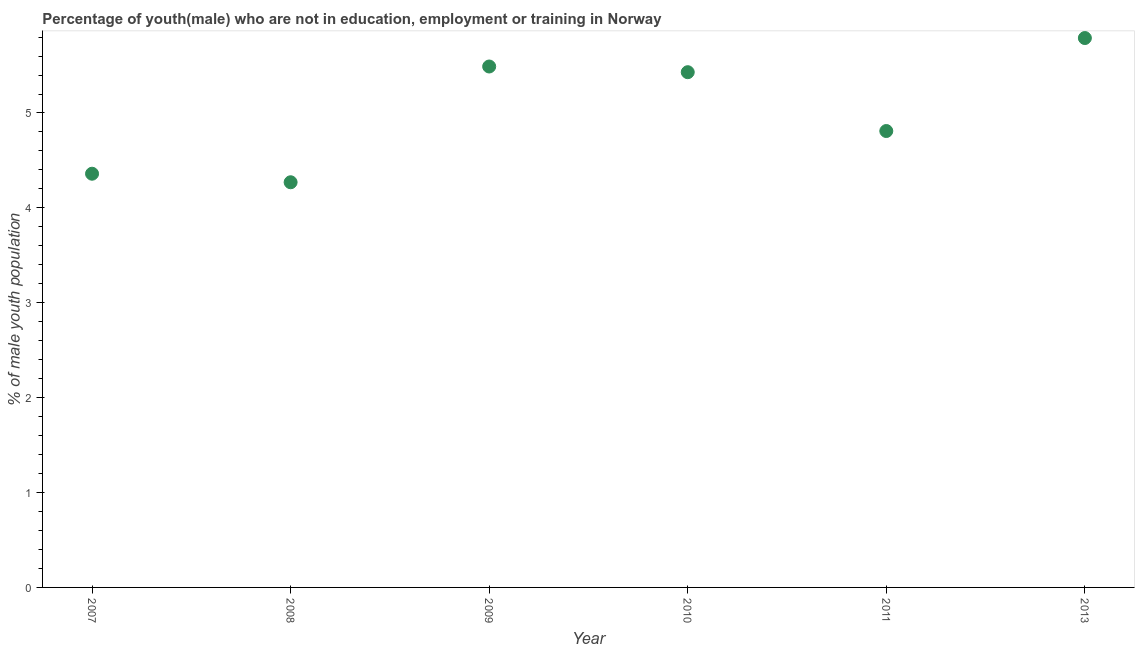What is the unemployed male youth population in 2013?
Your response must be concise. 5.79. Across all years, what is the maximum unemployed male youth population?
Your answer should be very brief. 5.79. Across all years, what is the minimum unemployed male youth population?
Your answer should be compact. 4.27. In which year was the unemployed male youth population maximum?
Offer a very short reply. 2013. What is the sum of the unemployed male youth population?
Offer a terse response. 30.15. What is the difference between the unemployed male youth population in 2008 and 2011?
Your answer should be very brief. -0.54. What is the average unemployed male youth population per year?
Make the answer very short. 5.02. What is the median unemployed male youth population?
Provide a short and direct response. 5.12. In how many years, is the unemployed male youth population greater than 0.8 %?
Provide a succinct answer. 6. What is the ratio of the unemployed male youth population in 2008 to that in 2009?
Provide a short and direct response. 0.78. Is the unemployed male youth population in 2011 less than that in 2013?
Your response must be concise. Yes. Is the difference between the unemployed male youth population in 2008 and 2013 greater than the difference between any two years?
Offer a very short reply. Yes. What is the difference between the highest and the second highest unemployed male youth population?
Make the answer very short. 0.3. What is the difference between the highest and the lowest unemployed male youth population?
Provide a short and direct response. 1.52. Does the unemployed male youth population monotonically increase over the years?
Provide a succinct answer. No. How many dotlines are there?
Offer a terse response. 1. What is the difference between two consecutive major ticks on the Y-axis?
Your answer should be compact. 1. Are the values on the major ticks of Y-axis written in scientific E-notation?
Your answer should be compact. No. What is the title of the graph?
Offer a very short reply. Percentage of youth(male) who are not in education, employment or training in Norway. What is the label or title of the X-axis?
Your response must be concise. Year. What is the label or title of the Y-axis?
Provide a succinct answer. % of male youth population. What is the % of male youth population in 2007?
Provide a short and direct response. 4.36. What is the % of male youth population in 2008?
Provide a short and direct response. 4.27. What is the % of male youth population in 2009?
Give a very brief answer. 5.49. What is the % of male youth population in 2010?
Provide a succinct answer. 5.43. What is the % of male youth population in 2011?
Give a very brief answer. 4.81. What is the % of male youth population in 2013?
Give a very brief answer. 5.79. What is the difference between the % of male youth population in 2007 and 2008?
Give a very brief answer. 0.09. What is the difference between the % of male youth population in 2007 and 2009?
Keep it short and to the point. -1.13. What is the difference between the % of male youth population in 2007 and 2010?
Offer a very short reply. -1.07. What is the difference between the % of male youth population in 2007 and 2011?
Your answer should be compact. -0.45. What is the difference between the % of male youth population in 2007 and 2013?
Make the answer very short. -1.43. What is the difference between the % of male youth population in 2008 and 2009?
Keep it short and to the point. -1.22. What is the difference between the % of male youth population in 2008 and 2010?
Your response must be concise. -1.16. What is the difference between the % of male youth population in 2008 and 2011?
Your answer should be compact. -0.54. What is the difference between the % of male youth population in 2008 and 2013?
Make the answer very short. -1.52. What is the difference between the % of male youth population in 2009 and 2010?
Make the answer very short. 0.06. What is the difference between the % of male youth population in 2009 and 2011?
Offer a terse response. 0.68. What is the difference between the % of male youth population in 2010 and 2011?
Your answer should be very brief. 0.62. What is the difference between the % of male youth population in 2010 and 2013?
Ensure brevity in your answer.  -0.36. What is the difference between the % of male youth population in 2011 and 2013?
Offer a very short reply. -0.98. What is the ratio of the % of male youth population in 2007 to that in 2009?
Give a very brief answer. 0.79. What is the ratio of the % of male youth population in 2007 to that in 2010?
Your answer should be very brief. 0.8. What is the ratio of the % of male youth population in 2007 to that in 2011?
Your answer should be compact. 0.91. What is the ratio of the % of male youth population in 2007 to that in 2013?
Offer a very short reply. 0.75. What is the ratio of the % of male youth population in 2008 to that in 2009?
Provide a short and direct response. 0.78. What is the ratio of the % of male youth population in 2008 to that in 2010?
Provide a succinct answer. 0.79. What is the ratio of the % of male youth population in 2008 to that in 2011?
Offer a terse response. 0.89. What is the ratio of the % of male youth population in 2008 to that in 2013?
Give a very brief answer. 0.74. What is the ratio of the % of male youth population in 2009 to that in 2010?
Keep it short and to the point. 1.01. What is the ratio of the % of male youth population in 2009 to that in 2011?
Make the answer very short. 1.14. What is the ratio of the % of male youth population in 2009 to that in 2013?
Ensure brevity in your answer.  0.95. What is the ratio of the % of male youth population in 2010 to that in 2011?
Your answer should be very brief. 1.13. What is the ratio of the % of male youth population in 2010 to that in 2013?
Make the answer very short. 0.94. What is the ratio of the % of male youth population in 2011 to that in 2013?
Offer a very short reply. 0.83. 